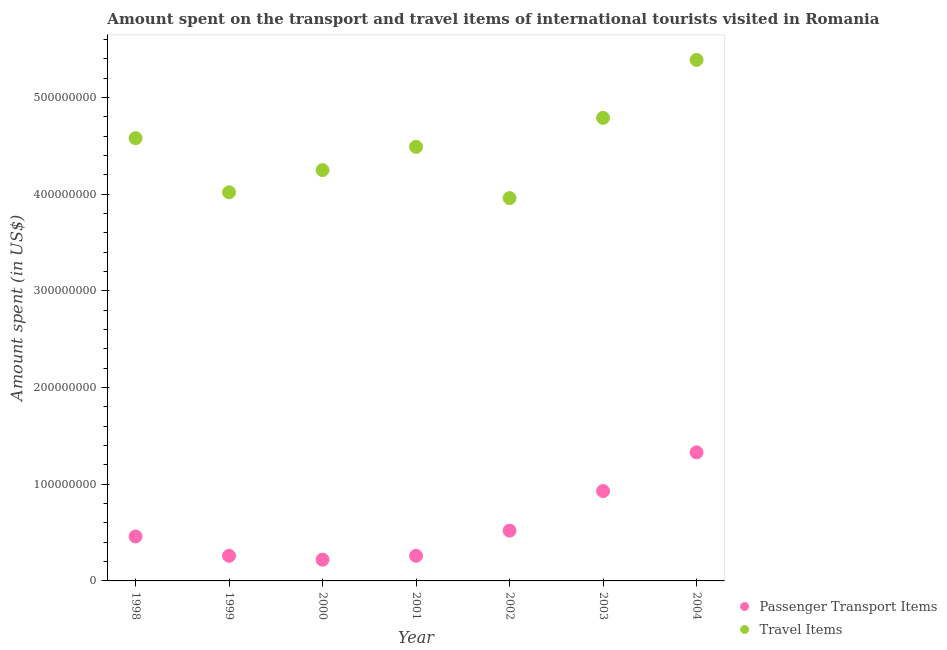How many different coloured dotlines are there?
Offer a terse response. 2. Is the number of dotlines equal to the number of legend labels?
Give a very brief answer. Yes. What is the amount spent on passenger transport items in 2002?
Offer a terse response. 5.20e+07. Across all years, what is the maximum amount spent in travel items?
Keep it short and to the point. 5.39e+08. Across all years, what is the minimum amount spent on passenger transport items?
Give a very brief answer. 2.20e+07. What is the total amount spent in travel items in the graph?
Your answer should be very brief. 3.15e+09. What is the difference between the amount spent on passenger transport items in 2000 and that in 2001?
Keep it short and to the point. -4.00e+06. What is the difference between the amount spent in travel items in 2002 and the amount spent on passenger transport items in 1998?
Provide a succinct answer. 3.50e+08. What is the average amount spent in travel items per year?
Your answer should be compact. 4.50e+08. In the year 2002, what is the difference between the amount spent on passenger transport items and amount spent in travel items?
Offer a very short reply. -3.44e+08. In how many years, is the amount spent on passenger transport items greater than 100000000 US$?
Your response must be concise. 1. What is the ratio of the amount spent in travel items in 2000 to that in 2002?
Offer a terse response. 1.07. What is the difference between the highest and the second highest amount spent in travel items?
Give a very brief answer. 6.00e+07. What is the difference between the highest and the lowest amount spent in travel items?
Ensure brevity in your answer.  1.43e+08. Is the amount spent in travel items strictly greater than the amount spent on passenger transport items over the years?
Your answer should be compact. Yes. What is the difference between two consecutive major ticks on the Y-axis?
Your answer should be compact. 1.00e+08. Does the graph contain grids?
Offer a terse response. No. What is the title of the graph?
Your answer should be compact. Amount spent on the transport and travel items of international tourists visited in Romania. Does "International Visitors" appear as one of the legend labels in the graph?
Provide a short and direct response. No. What is the label or title of the X-axis?
Your response must be concise. Year. What is the label or title of the Y-axis?
Provide a short and direct response. Amount spent (in US$). What is the Amount spent (in US$) in Passenger Transport Items in 1998?
Ensure brevity in your answer.  4.60e+07. What is the Amount spent (in US$) of Travel Items in 1998?
Your response must be concise. 4.58e+08. What is the Amount spent (in US$) of Passenger Transport Items in 1999?
Ensure brevity in your answer.  2.60e+07. What is the Amount spent (in US$) of Travel Items in 1999?
Keep it short and to the point. 4.02e+08. What is the Amount spent (in US$) of Passenger Transport Items in 2000?
Provide a succinct answer. 2.20e+07. What is the Amount spent (in US$) of Travel Items in 2000?
Make the answer very short. 4.25e+08. What is the Amount spent (in US$) in Passenger Transport Items in 2001?
Your response must be concise. 2.60e+07. What is the Amount spent (in US$) in Travel Items in 2001?
Ensure brevity in your answer.  4.49e+08. What is the Amount spent (in US$) in Passenger Transport Items in 2002?
Provide a succinct answer. 5.20e+07. What is the Amount spent (in US$) in Travel Items in 2002?
Provide a short and direct response. 3.96e+08. What is the Amount spent (in US$) in Passenger Transport Items in 2003?
Your answer should be compact. 9.30e+07. What is the Amount spent (in US$) of Travel Items in 2003?
Make the answer very short. 4.79e+08. What is the Amount spent (in US$) in Passenger Transport Items in 2004?
Offer a very short reply. 1.33e+08. What is the Amount spent (in US$) in Travel Items in 2004?
Your response must be concise. 5.39e+08. Across all years, what is the maximum Amount spent (in US$) in Passenger Transport Items?
Your answer should be compact. 1.33e+08. Across all years, what is the maximum Amount spent (in US$) of Travel Items?
Your response must be concise. 5.39e+08. Across all years, what is the minimum Amount spent (in US$) in Passenger Transport Items?
Your answer should be compact. 2.20e+07. Across all years, what is the minimum Amount spent (in US$) in Travel Items?
Keep it short and to the point. 3.96e+08. What is the total Amount spent (in US$) in Passenger Transport Items in the graph?
Keep it short and to the point. 3.98e+08. What is the total Amount spent (in US$) of Travel Items in the graph?
Provide a succinct answer. 3.15e+09. What is the difference between the Amount spent (in US$) in Passenger Transport Items in 1998 and that in 1999?
Offer a terse response. 2.00e+07. What is the difference between the Amount spent (in US$) of Travel Items in 1998 and that in 1999?
Give a very brief answer. 5.60e+07. What is the difference between the Amount spent (in US$) in Passenger Transport Items in 1998 and that in 2000?
Provide a short and direct response. 2.40e+07. What is the difference between the Amount spent (in US$) of Travel Items in 1998 and that in 2000?
Keep it short and to the point. 3.30e+07. What is the difference between the Amount spent (in US$) in Passenger Transport Items in 1998 and that in 2001?
Keep it short and to the point. 2.00e+07. What is the difference between the Amount spent (in US$) of Travel Items in 1998 and that in 2001?
Ensure brevity in your answer.  9.00e+06. What is the difference between the Amount spent (in US$) of Passenger Transport Items in 1998 and that in 2002?
Keep it short and to the point. -6.00e+06. What is the difference between the Amount spent (in US$) in Travel Items in 1998 and that in 2002?
Ensure brevity in your answer.  6.20e+07. What is the difference between the Amount spent (in US$) of Passenger Transport Items in 1998 and that in 2003?
Provide a short and direct response. -4.70e+07. What is the difference between the Amount spent (in US$) in Travel Items in 1998 and that in 2003?
Your answer should be very brief. -2.10e+07. What is the difference between the Amount spent (in US$) in Passenger Transport Items in 1998 and that in 2004?
Ensure brevity in your answer.  -8.70e+07. What is the difference between the Amount spent (in US$) in Travel Items in 1998 and that in 2004?
Make the answer very short. -8.10e+07. What is the difference between the Amount spent (in US$) of Passenger Transport Items in 1999 and that in 2000?
Your answer should be compact. 4.00e+06. What is the difference between the Amount spent (in US$) in Travel Items in 1999 and that in 2000?
Offer a terse response. -2.30e+07. What is the difference between the Amount spent (in US$) in Travel Items in 1999 and that in 2001?
Your answer should be very brief. -4.70e+07. What is the difference between the Amount spent (in US$) of Passenger Transport Items in 1999 and that in 2002?
Make the answer very short. -2.60e+07. What is the difference between the Amount spent (in US$) of Passenger Transport Items in 1999 and that in 2003?
Make the answer very short. -6.70e+07. What is the difference between the Amount spent (in US$) in Travel Items in 1999 and that in 2003?
Your response must be concise. -7.70e+07. What is the difference between the Amount spent (in US$) in Passenger Transport Items in 1999 and that in 2004?
Your answer should be compact. -1.07e+08. What is the difference between the Amount spent (in US$) in Travel Items in 1999 and that in 2004?
Provide a succinct answer. -1.37e+08. What is the difference between the Amount spent (in US$) in Passenger Transport Items in 2000 and that in 2001?
Keep it short and to the point. -4.00e+06. What is the difference between the Amount spent (in US$) of Travel Items in 2000 and that in 2001?
Offer a terse response. -2.40e+07. What is the difference between the Amount spent (in US$) of Passenger Transport Items in 2000 and that in 2002?
Make the answer very short. -3.00e+07. What is the difference between the Amount spent (in US$) of Travel Items in 2000 and that in 2002?
Offer a very short reply. 2.90e+07. What is the difference between the Amount spent (in US$) of Passenger Transport Items in 2000 and that in 2003?
Provide a succinct answer. -7.10e+07. What is the difference between the Amount spent (in US$) of Travel Items in 2000 and that in 2003?
Keep it short and to the point. -5.40e+07. What is the difference between the Amount spent (in US$) of Passenger Transport Items in 2000 and that in 2004?
Your response must be concise. -1.11e+08. What is the difference between the Amount spent (in US$) of Travel Items in 2000 and that in 2004?
Make the answer very short. -1.14e+08. What is the difference between the Amount spent (in US$) of Passenger Transport Items in 2001 and that in 2002?
Offer a very short reply. -2.60e+07. What is the difference between the Amount spent (in US$) of Travel Items in 2001 and that in 2002?
Offer a very short reply. 5.30e+07. What is the difference between the Amount spent (in US$) in Passenger Transport Items in 2001 and that in 2003?
Keep it short and to the point. -6.70e+07. What is the difference between the Amount spent (in US$) in Travel Items in 2001 and that in 2003?
Provide a short and direct response. -3.00e+07. What is the difference between the Amount spent (in US$) of Passenger Transport Items in 2001 and that in 2004?
Give a very brief answer. -1.07e+08. What is the difference between the Amount spent (in US$) of Travel Items in 2001 and that in 2004?
Ensure brevity in your answer.  -9.00e+07. What is the difference between the Amount spent (in US$) in Passenger Transport Items in 2002 and that in 2003?
Your response must be concise. -4.10e+07. What is the difference between the Amount spent (in US$) in Travel Items in 2002 and that in 2003?
Make the answer very short. -8.30e+07. What is the difference between the Amount spent (in US$) of Passenger Transport Items in 2002 and that in 2004?
Your response must be concise. -8.10e+07. What is the difference between the Amount spent (in US$) of Travel Items in 2002 and that in 2004?
Offer a terse response. -1.43e+08. What is the difference between the Amount spent (in US$) of Passenger Transport Items in 2003 and that in 2004?
Offer a very short reply. -4.00e+07. What is the difference between the Amount spent (in US$) in Travel Items in 2003 and that in 2004?
Your answer should be compact. -6.00e+07. What is the difference between the Amount spent (in US$) of Passenger Transport Items in 1998 and the Amount spent (in US$) of Travel Items in 1999?
Ensure brevity in your answer.  -3.56e+08. What is the difference between the Amount spent (in US$) of Passenger Transport Items in 1998 and the Amount spent (in US$) of Travel Items in 2000?
Offer a very short reply. -3.79e+08. What is the difference between the Amount spent (in US$) of Passenger Transport Items in 1998 and the Amount spent (in US$) of Travel Items in 2001?
Ensure brevity in your answer.  -4.03e+08. What is the difference between the Amount spent (in US$) of Passenger Transport Items in 1998 and the Amount spent (in US$) of Travel Items in 2002?
Your response must be concise. -3.50e+08. What is the difference between the Amount spent (in US$) of Passenger Transport Items in 1998 and the Amount spent (in US$) of Travel Items in 2003?
Offer a very short reply. -4.33e+08. What is the difference between the Amount spent (in US$) of Passenger Transport Items in 1998 and the Amount spent (in US$) of Travel Items in 2004?
Make the answer very short. -4.93e+08. What is the difference between the Amount spent (in US$) of Passenger Transport Items in 1999 and the Amount spent (in US$) of Travel Items in 2000?
Give a very brief answer. -3.99e+08. What is the difference between the Amount spent (in US$) in Passenger Transport Items in 1999 and the Amount spent (in US$) in Travel Items in 2001?
Make the answer very short. -4.23e+08. What is the difference between the Amount spent (in US$) in Passenger Transport Items in 1999 and the Amount spent (in US$) in Travel Items in 2002?
Offer a terse response. -3.70e+08. What is the difference between the Amount spent (in US$) in Passenger Transport Items in 1999 and the Amount spent (in US$) in Travel Items in 2003?
Give a very brief answer. -4.53e+08. What is the difference between the Amount spent (in US$) of Passenger Transport Items in 1999 and the Amount spent (in US$) of Travel Items in 2004?
Your response must be concise. -5.13e+08. What is the difference between the Amount spent (in US$) of Passenger Transport Items in 2000 and the Amount spent (in US$) of Travel Items in 2001?
Provide a short and direct response. -4.27e+08. What is the difference between the Amount spent (in US$) of Passenger Transport Items in 2000 and the Amount spent (in US$) of Travel Items in 2002?
Your response must be concise. -3.74e+08. What is the difference between the Amount spent (in US$) of Passenger Transport Items in 2000 and the Amount spent (in US$) of Travel Items in 2003?
Provide a short and direct response. -4.57e+08. What is the difference between the Amount spent (in US$) of Passenger Transport Items in 2000 and the Amount spent (in US$) of Travel Items in 2004?
Offer a very short reply. -5.17e+08. What is the difference between the Amount spent (in US$) of Passenger Transport Items in 2001 and the Amount spent (in US$) of Travel Items in 2002?
Make the answer very short. -3.70e+08. What is the difference between the Amount spent (in US$) of Passenger Transport Items in 2001 and the Amount spent (in US$) of Travel Items in 2003?
Your answer should be compact. -4.53e+08. What is the difference between the Amount spent (in US$) of Passenger Transport Items in 2001 and the Amount spent (in US$) of Travel Items in 2004?
Ensure brevity in your answer.  -5.13e+08. What is the difference between the Amount spent (in US$) of Passenger Transport Items in 2002 and the Amount spent (in US$) of Travel Items in 2003?
Offer a very short reply. -4.27e+08. What is the difference between the Amount spent (in US$) in Passenger Transport Items in 2002 and the Amount spent (in US$) in Travel Items in 2004?
Make the answer very short. -4.87e+08. What is the difference between the Amount spent (in US$) in Passenger Transport Items in 2003 and the Amount spent (in US$) in Travel Items in 2004?
Offer a terse response. -4.46e+08. What is the average Amount spent (in US$) in Passenger Transport Items per year?
Offer a very short reply. 5.69e+07. What is the average Amount spent (in US$) of Travel Items per year?
Provide a short and direct response. 4.50e+08. In the year 1998, what is the difference between the Amount spent (in US$) in Passenger Transport Items and Amount spent (in US$) in Travel Items?
Your answer should be very brief. -4.12e+08. In the year 1999, what is the difference between the Amount spent (in US$) of Passenger Transport Items and Amount spent (in US$) of Travel Items?
Give a very brief answer. -3.76e+08. In the year 2000, what is the difference between the Amount spent (in US$) in Passenger Transport Items and Amount spent (in US$) in Travel Items?
Offer a very short reply. -4.03e+08. In the year 2001, what is the difference between the Amount spent (in US$) in Passenger Transport Items and Amount spent (in US$) in Travel Items?
Provide a short and direct response. -4.23e+08. In the year 2002, what is the difference between the Amount spent (in US$) in Passenger Transport Items and Amount spent (in US$) in Travel Items?
Give a very brief answer. -3.44e+08. In the year 2003, what is the difference between the Amount spent (in US$) in Passenger Transport Items and Amount spent (in US$) in Travel Items?
Your answer should be very brief. -3.86e+08. In the year 2004, what is the difference between the Amount spent (in US$) in Passenger Transport Items and Amount spent (in US$) in Travel Items?
Offer a very short reply. -4.06e+08. What is the ratio of the Amount spent (in US$) of Passenger Transport Items in 1998 to that in 1999?
Ensure brevity in your answer.  1.77. What is the ratio of the Amount spent (in US$) of Travel Items in 1998 to that in 1999?
Your answer should be very brief. 1.14. What is the ratio of the Amount spent (in US$) of Passenger Transport Items in 1998 to that in 2000?
Provide a succinct answer. 2.09. What is the ratio of the Amount spent (in US$) in Travel Items in 1998 to that in 2000?
Your answer should be very brief. 1.08. What is the ratio of the Amount spent (in US$) in Passenger Transport Items in 1998 to that in 2001?
Your answer should be very brief. 1.77. What is the ratio of the Amount spent (in US$) in Passenger Transport Items in 1998 to that in 2002?
Keep it short and to the point. 0.88. What is the ratio of the Amount spent (in US$) of Travel Items in 1998 to that in 2002?
Your response must be concise. 1.16. What is the ratio of the Amount spent (in US$) in Passenger Transport Items in 1998 to that in 2003?
Make the answer very short. 0.49. What is the ratio of the Amount spent (in US$) of Travel Items in 1998 to that in 2003?
Your answer should be compact. 0.96. What is the ratio of the Amount spent (in US$) in Passenger Transport Items in 1998 to that in 2004?
Make the answer very short. 0.35. What is the ratio of the Amount spent (in US$) of Travel Items in 1998 to that in 2004?
Give a very brief answer. 0.85. What is the ratio of the Amount spent (in US$) of Passenger Transport Items in 1999 to that in 2000?
Provide a succinct answer. 1.18. What is the ratio of the Amount spent (in US$) in Travel Items in 1999 to that in 2000?
Offer a very short reply. 0.95. What is the ratio of the Amount spent (in US$) of Passenger Transport Items in 1999 to that in 2001?
Provide a succinct answer. 1. What is the ratio of the Amount spent (in US$) in Travel Items in 1999 to that in 2001?
Ensure brevity in your answer.  0.9. What is the ratio of the Amount spent (in US$) of Travel Items in 1999 to that in 2002?
Make the answer very short. 1.02. What is the ratio of the Amount spent (in US$) of Passenger Transport Items in 1999 to that in 2003?
Provide a short and direct response. 0.28. What is the ratio of the Amount spent (in US$) in Travel Items in 1999 to that in 2003?
Your answer should be compact. 0.84. What is the ratio of the Amount spent (in US$) in Passenger Transport Items in 1999 to that in 2004?
Give a very brief answer. 0.2. What is the ratio of the Amount spent (in US$) in Travel Items in 1999 to that in 2004?
Provide a short and direct response. 0.75. What is the ratio of the Amount spent (in US$) of Passenger Transport Items in 2000 to that in 2001?
Your answer should be compact. 0.85. What is the ratio of the Amount spent (in US$) in Travel Items in 2000 to that in 2001?
Ensure brevity in your answer.  0.95. What is the ratio of the Amount spent (in US$) in Passenger Transport Items in 2000 to that in 2002?
Your answer should be very brief. 0.42. What is the ratio of the Amount spent (in US$) in Travel Items in 2000 to that in 2002?
Offer a very short reply. 1.07. What is the ratio of the Amount spent (in US$) of Passenger Transport Items in 2000 to that in 2003?
Your answer should be very brief. 0.24. What is the ratio of the Amount spent (in US$) of Travel Items in 2000 to that in 2003?
Ensure brevity in your answer.  0.89. What is the ratio of the Amount spent (in US$) of Passenger Transport Items in 2000 to that in 2004?
Provide a short and direct response. 0.17. What is the ratio of the Amount spent (in US$) in Travel Items in 2000 to that in 2004?
Give a very brief answer. 0.79. What is the ratio of the Amount spent (in US$) in Travel Items in 2001 to that in 2002?
Keep it short and to the point. 1.13. What is the ratio of the Amount spent (in US$) in Passenger Transport Items in 2001 to that in 2003?
Your answer should be very brief. 0.28. What is the ratio of the Amount spent (in US$) in Travel Items in 2001 to that in 2003?
Your response must be concise. 0.94. What is the ratio of the Amount spent (in US$) in Passenger Transport Items in 2001 to that in 2004?
Offer a very short reply. 0.2. What is the ratio of the Amount spent (in US$) in Travel Items in 2001 to that in 2004?
Offer a terse response. 0.83. What is the ratio of the Amount spent (in US$) in Passenger Transport Items in 2002 to that in 2003?
Give a very brief answer. 0.56. What is the ratio of the Amount spent (in US$) in Travel Items in 2002 to that in 2003?
Your answer should be very brief. 0.83. What is the ratio of the Amount spent (in US$) in Passenger Transport Items in 2002 to that in 2004?
Your response must be concise. 0.39. What is the ratio of the Amount spent (in US$) in Travel Items in 2002 to that in 2004?
Your answer should be very brief. 0.73. What is the ratio of the Amount spent (in US$) in Passenger Transport Items in 2003 to that in 2004?
Provide a short and direct response. 0.7. What is the ratio of the Amount spent (in US$) in Travel Items in 2003 to that in 2004?
Provide a succinct answer. 0.89. What is the difference between the highest and the second highest Amount spent (in US$) of Passenger Transport Items?
Your answer should be very brief. 4.00e+07. What is the difference between the highest and the second highest Amount spent (in US$) in Travel Items?
Give a very brief answer. 6.00e+07. What is the difference between the highest and the lowest Amount spent (in US$) of Passenger Transport Items?
Offer a very short reply. 1.11e+08. What is the difference between the highest and the lowest Amount spent (in US$) in Travel Items?
Your answer should be compact. 1.43e+08. 